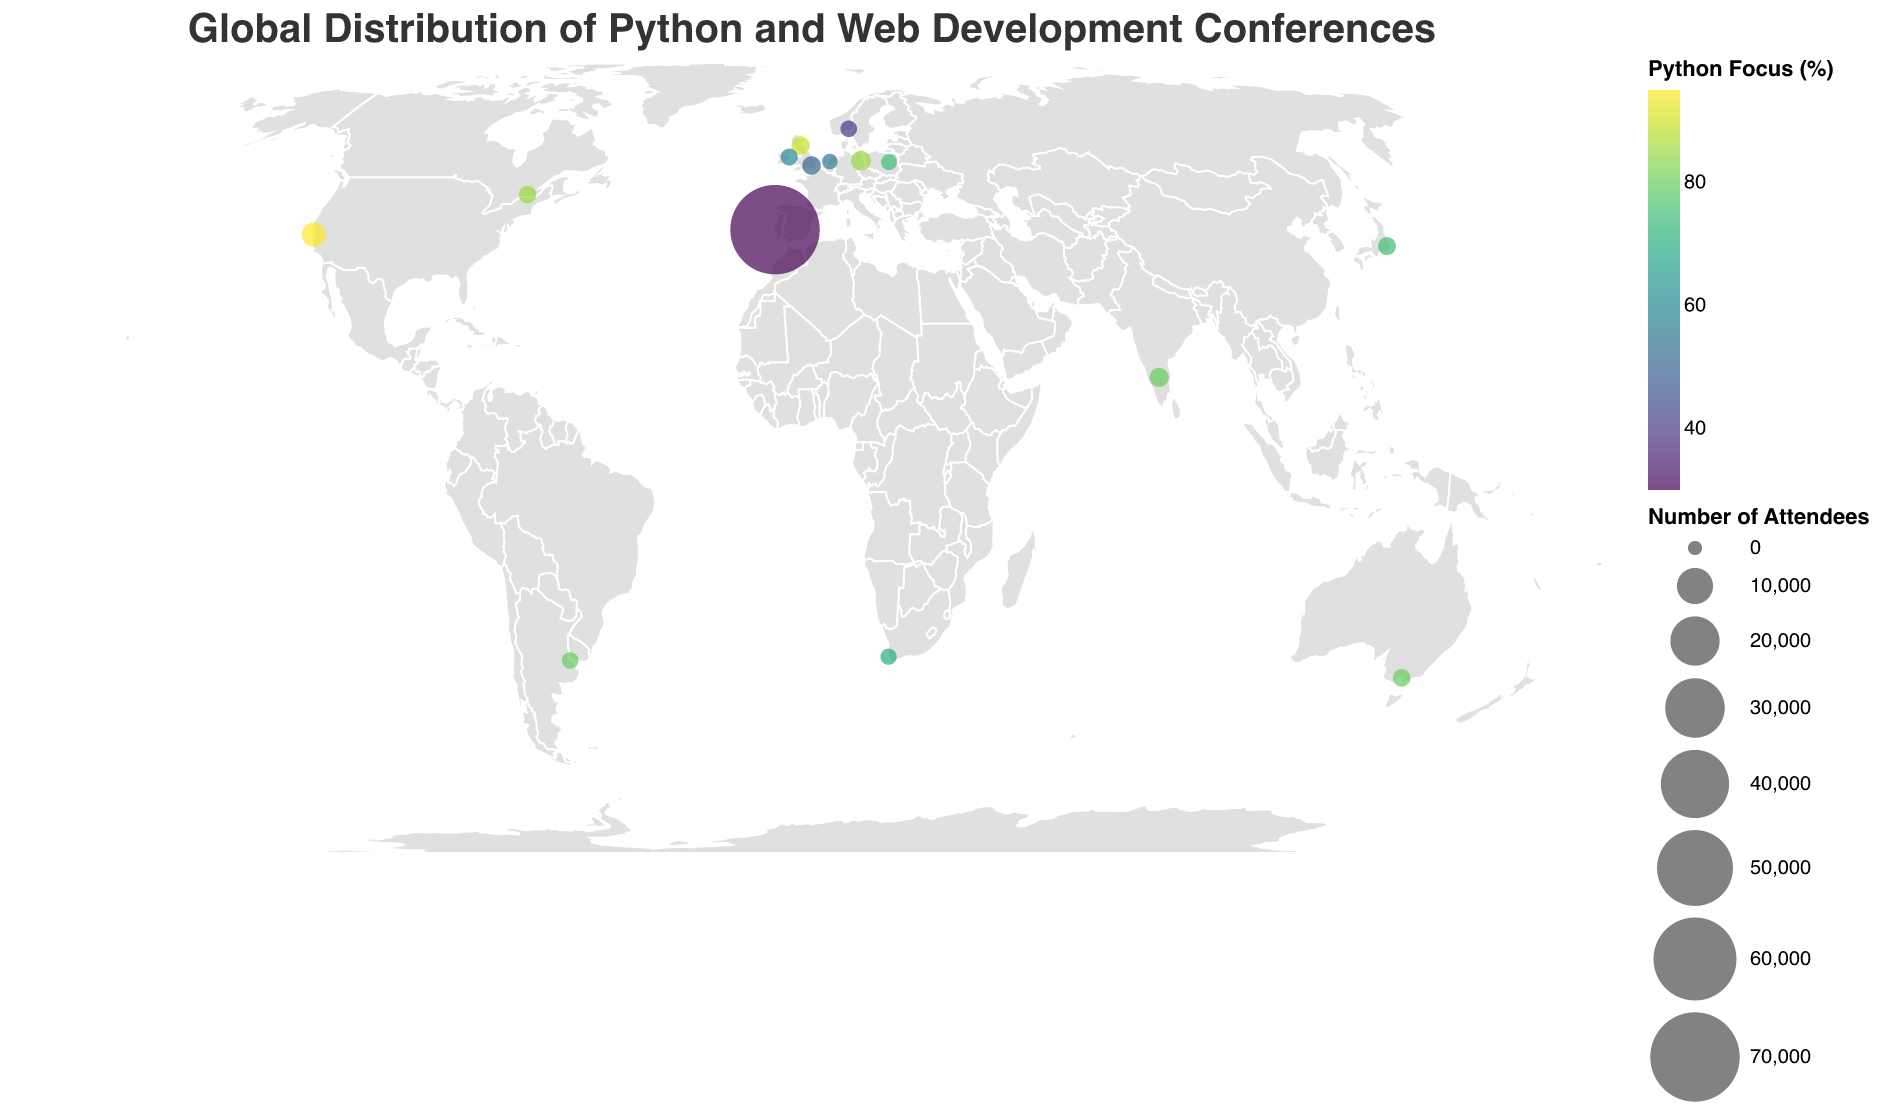What is the title of the figure? The title is prominently displayed at the top of the figure and outlines the main topic being visualized.
Answer: Global Distribution of Python and Web Development Conferences Which conference has the highest number of attendees? The size of the circles in the figure represents the number of attendees. The largest circle corresponds to the event with the highest number of attendees.
Answer: Web Summit in Lisbon Which conference has the highest Python focus? The color intensity of the circles represents the Python focus percentage, with darker colors indicating higher focus. The darkest circle represents the event with the highest Python focus.
Answer: PyCon US in San Francisco How many tech conferences are visualized in the figure? Count the number of circles on the map, as each circle represents a tech conference.
Answer: 15 Which European city hosts a tech conference with a high Python focus? Look at the circles located in Europe and find the one with a darker color, which indicates a higher Python focus.
Answer: Edinburgh (EdinPyConf) or Berlin (EuroPython) What is the average number of attendees for all the conferences displayed? Sum up all the attendees and divide by the number of conferences: (1200 + 3500 + 1800 + 1000 + 1100 + 600 + 800 + 950 + 400 + 1500 + 700 + 1300 + 70000 + 500 + 700) / 15.
Answer: 6196.67 Compare the PyCon conferences in different cities. Which city has the smallest PyCon event by attendees? Identify the cities with PyCon events and compare their attendee numbers. The smallest number of attendees indicates the smallest event.
Answer: Cape Town (PyCon ZA, 600 attendees) Which city in South America hosts a Python-focused tech conference? Identify the circle representing a city in South America and check its Python focus.
Answer: Buenos Aires (PyCon Argentina) What is the Python focus percentage of Django Day in Amsterdam? Check the color of the circle representing the event in Amsterdam and refer to the color legend to determine the Python focus percentage.
Answer: 55 